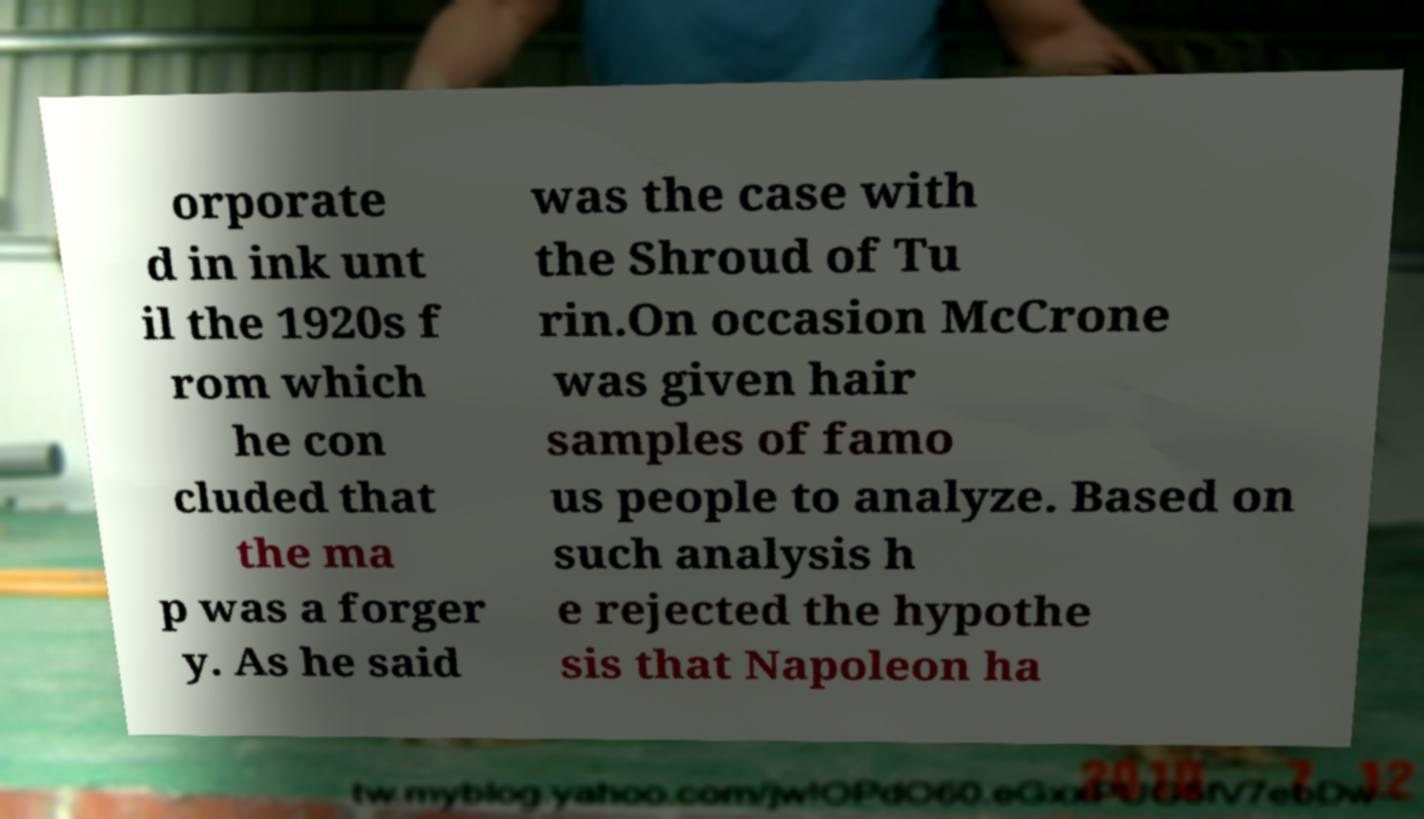I need the written content from this picture converted into text. Can you do that? orporate d in ink unt il the 1920s f rom which he con cluded that the ma p was a forger y. As he said was the case with the Shroud of Tu rin.On occasion McCrone was given hair samples of famo us people to analyze. Based on such analysis h e rejected the hypothe sis that Napoleon ha 